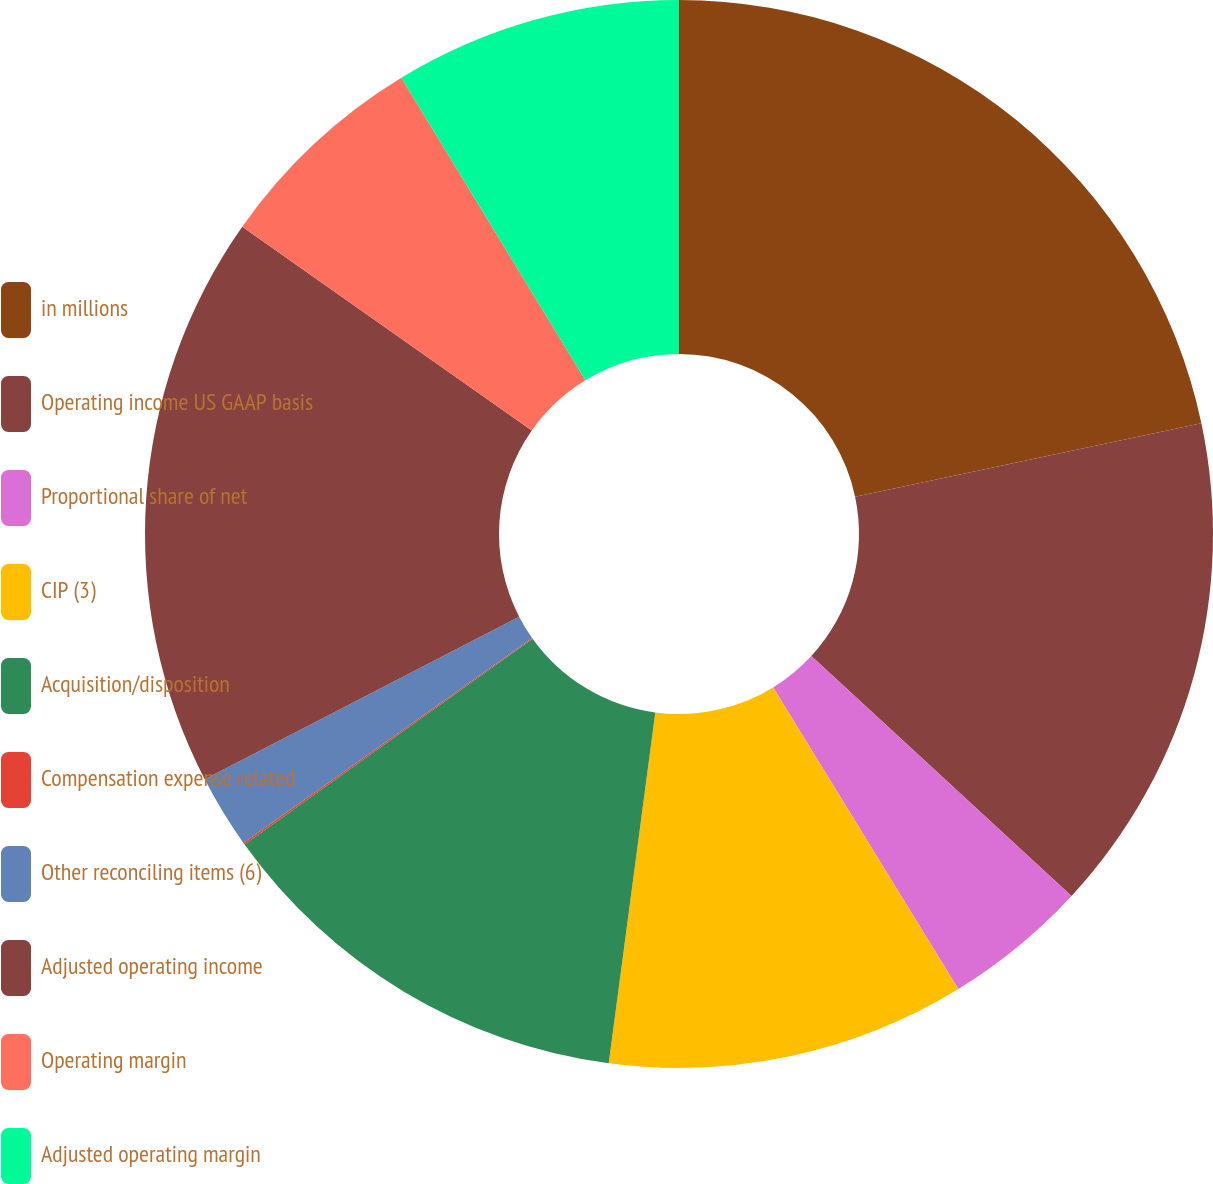Convert chart. <chart><loc_0><loc_0><loc_500><loc_500><pie_chart><fcel>in millions<fcel>Operating income US GAAP basis<fcel>Proportional share of net<fcel>CIP (3)<fcel>Acquisition/disposition<fcel>Compensation expense related<fcel>Other reconciling items (6)<fcel>Adjusted operating income<fcel>Operating margin<fcel>Adjusted operating margin<nl><fcel>21.67%<fcel>15.18%<fcel>4.38%<fcel>10.86%<fcel>13.02%<fcel>0.06%<fcel>2.22%<fcel>17.35%<fcel>6.54%<fcel>8.7%<nl></chart> 